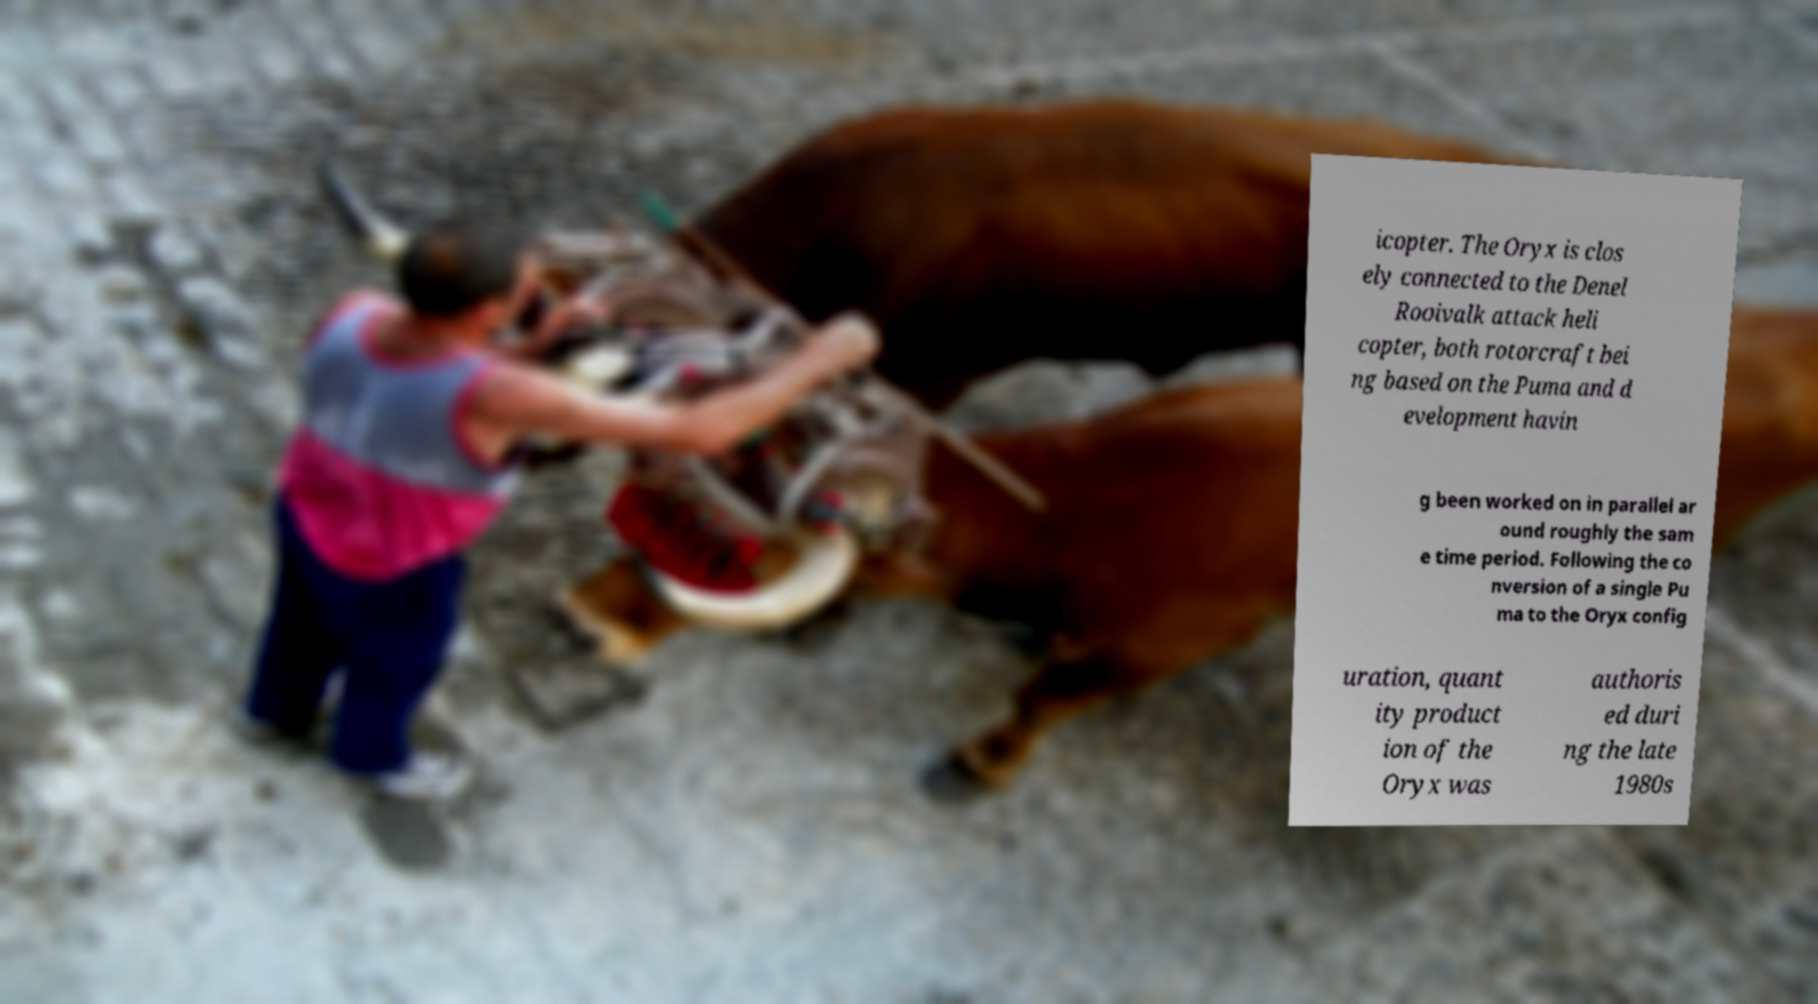Could you assist in decoding the text presented in this image and type it out clearly? icopter. The Oryx is clos ely connected to the Denel Rooivalk attack heli copter, both rotorcraft bei ng based on the Puma and d evelopment havin g been worked on in parallel ar ound roughly the sam e time period. Following the co nversion of a single Pu ma to the Oryx config uration, quant ity product ion of the Oryx was authoris ed duri ng the late 1980s 